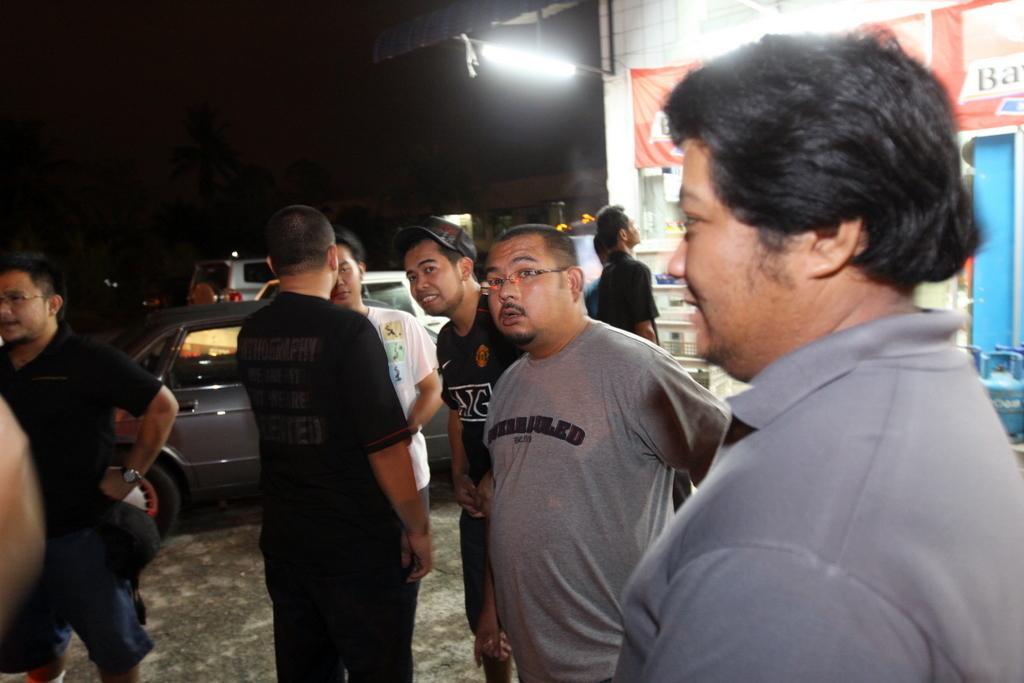In one or two sentences, can you explain what this image depicts? This image is taken outdoors. In this image the background is a little dark. A few cars are parked on the road. On the right side of the image there is a house. There is a banner with a text on it. In the middle of the image a few people are standing on the road. 